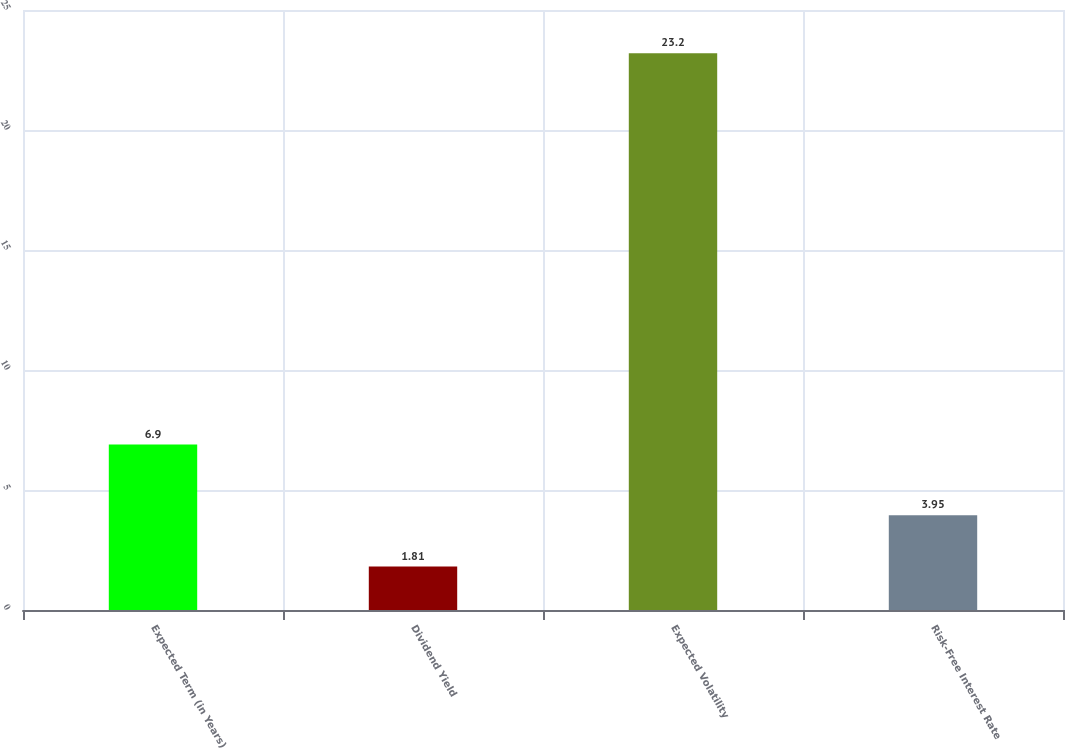Convert chart to OTSL. <chart><loc_0><loc_0><loc_500><loc_500><bar_chart><fcel>Expected Term (in Years)<fcel>Dividend Yield<fcel>Expected Volatility<fcel>Risk-Free Interest Rate<nl><fcel>6.9<fcel>1.81<fcel>23.2<fcel>3.95<nl></chart> 